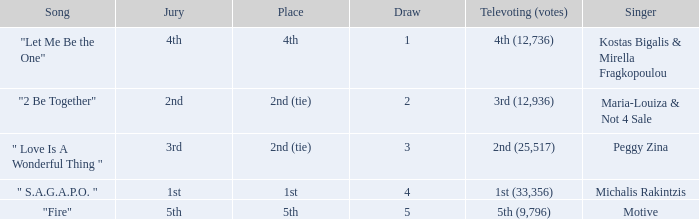Singer Maria-Louiza & Not 4 Sale had what jury? 2nd. 